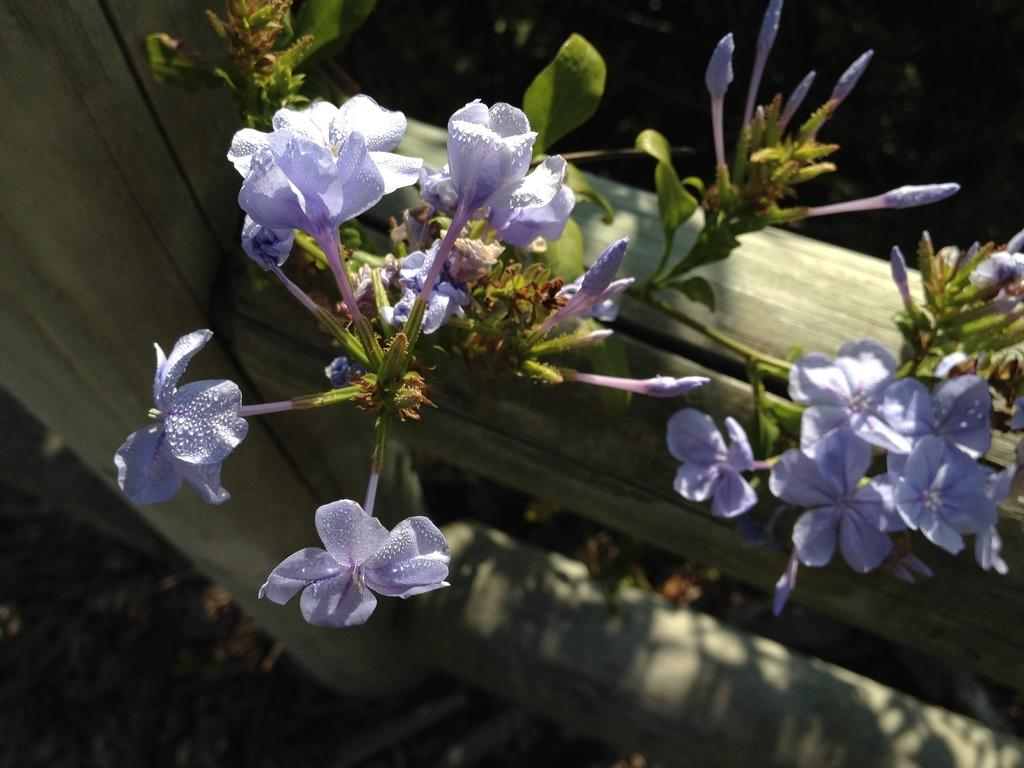What type of living organisms can be seen in the image? Plants can be seen in the image. What specific features are present on the plants? There are beautiful flowers on the plants. What type of design can be seen on the horse in the image? There is no horse present in the image; it features plants with beautiful flowers. 